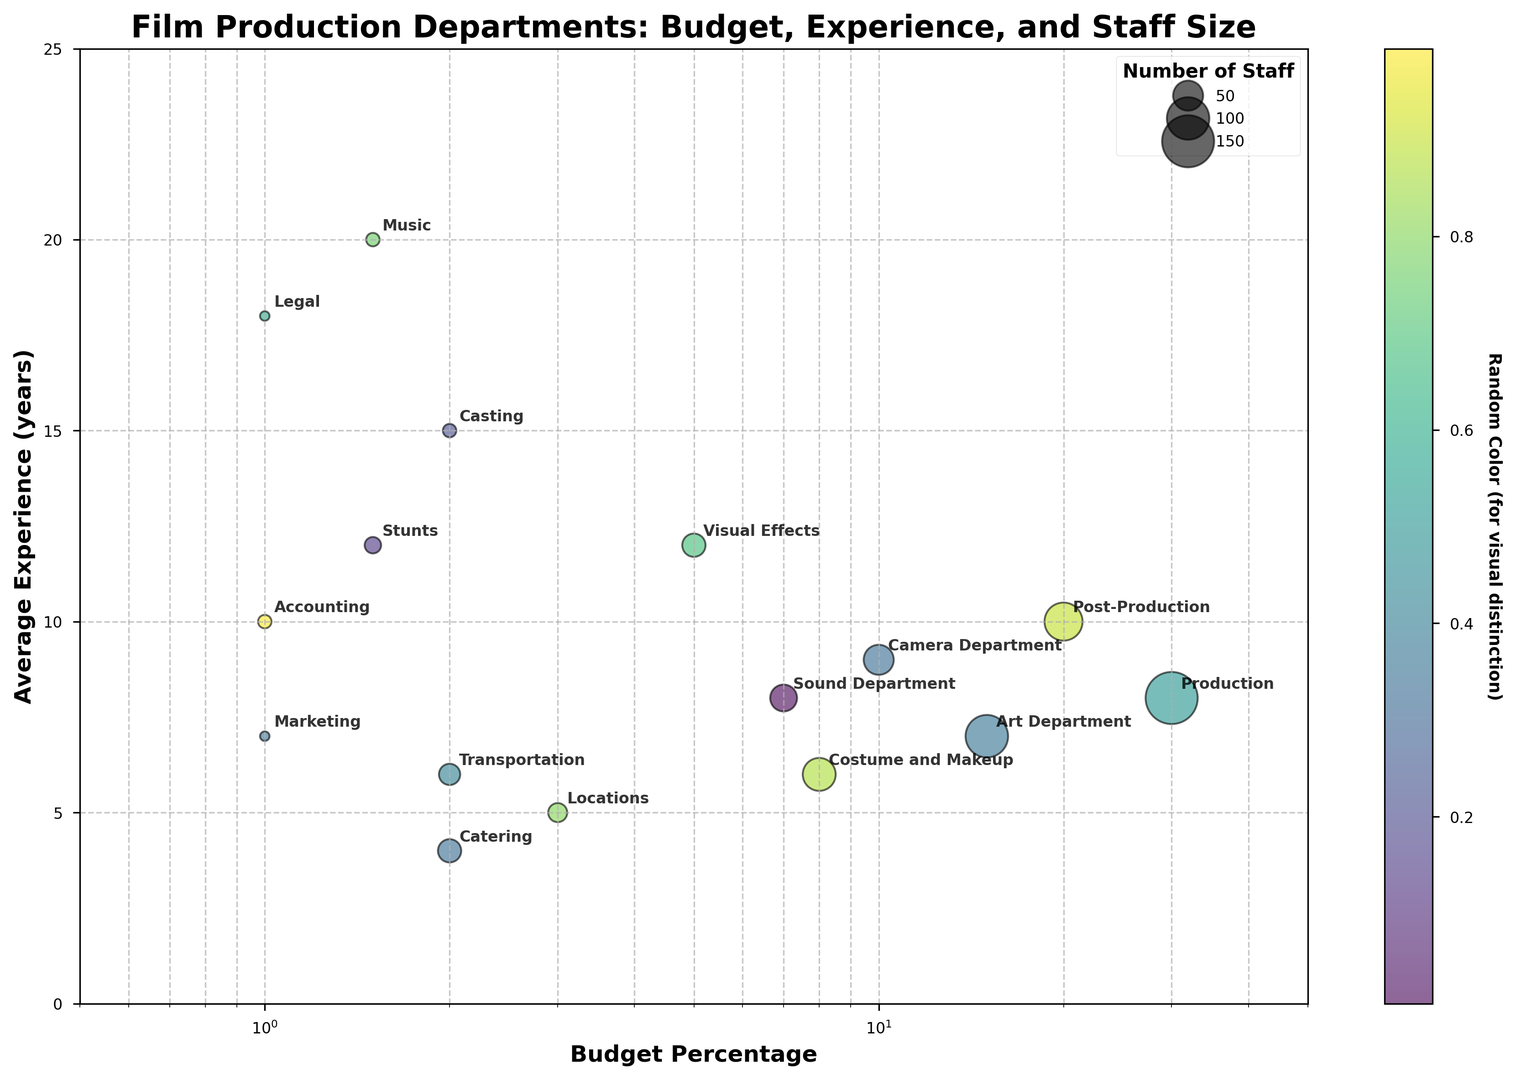What department has the highest budget percentage? The figure shows bubbles located on a logarithmic x-axis which represents the budget percentages. The department with the bubble farthest to the right indicates the highest budget percentage.
Answer: Production Which department has the most experienced staff on average? The y-axis represents average experience in years. The department with the bubble positioned highest on the y-axis has the most experienced staff on average.
Answer: Music What is the difference in average experience between the Visual Effects and Camera Department? Locate the Visual Effects and Camera Department bubbles on the y-axis and subtract the average experience values; Visual Effects has 12 years, and Camera Department has 9 years: 12 - 9 = 3.
Answer: 3 years Which two departments have the smallest number of staff? The bubbles' sizes correspond to the number of staff. The two smallest bubbles represent the departments with the smallest number of staff.
Answer: Marketing and Legal Compare the average experience between the Stunts and Accounting departments. Which one has more experienced staff? Locate the bubbles for Stunts and Accounting on the y-axis and compare their positions; Stunts is at 12 years and Accounting is at 10 years.
Answer: Stunts Which department allocates the least amount of budget? The x-axis on a logarithmic scale represents budget percentage. The department with the bubble farthest to the left (closest to 1%) allocates the least budget.
Answer: Legal, Accounting, and Casting What is the combined number of staff in the Production and Post-Production departments? Add the number of staff in the Production (150) and Post-Production (80) departments: 150 + 80 = 230.
Answer: 230 Which department has the highest average experience but the lowest budget percentage? Identify the department with the highest position on the y-axis (for experience) and verify that it is among those with the lowest position on the x-axis (budget percentage).
Answer: Music What is the relationship between budget percentage and number of staff in the Art Department? Observe the position and size of the Art Department bubble. It has a budget percentage of 15% and a number of staff of 100. There is a direct proportionality with a moderate budget and a relatively high number of staff.
Answer: Moderate budget, high staff Which department in the range of a 2-8% budget has the highest average experience? Look at bubbles between 2-8% on the x-axis and check their highest position on the y-axis; Costume and Makeup (6 years), Visual Effects (12 years), Sound Department (8 years).
Answer: Visual Effects 